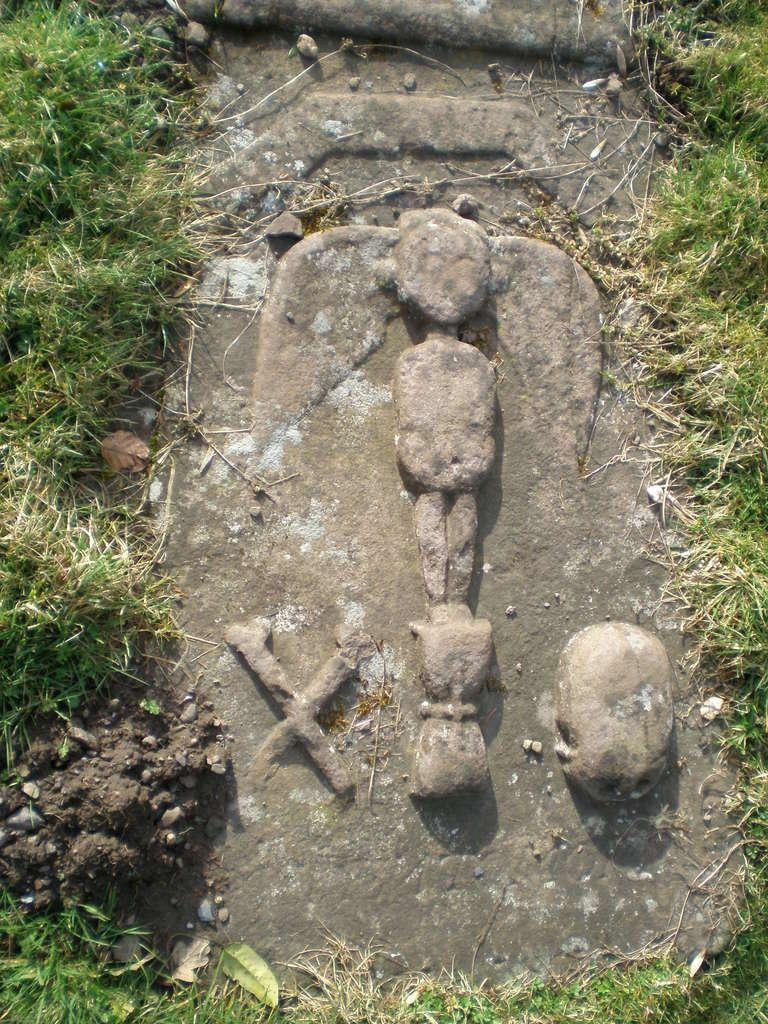What is the main subject in the image? There is a rock in the image. What type of vegetation can be seen on both sides of the rock? There is grass on the left side and right side of the image. What is the color of the grass in the image? The grass is green in color. What is the girl doing in the image? There is no girl present in the image; it features a rock and grass. What type of development is taking place in the image? There is no development or construction visible in the image; it shows a rock and grass. 